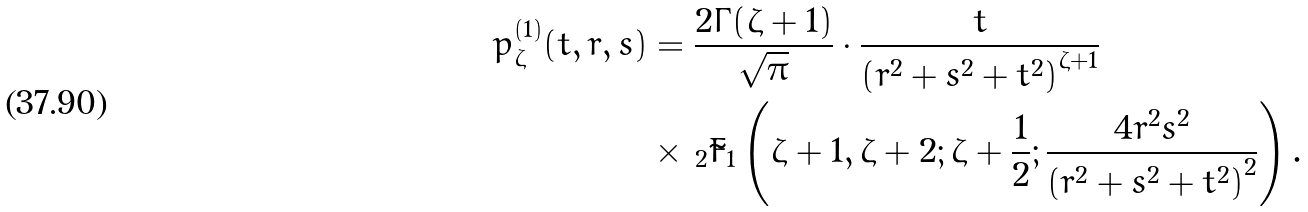<formula> <loc_0><loc_0><loc_500><loc_500>p _ { \zeta } ^ { ( 1 ) } ( t , r , s ) & = \frac { 2 \Gamma ( \zeta + 1 ) } { \sqrt { \pi } } \cdot \frac { t } { \left ( r ^ { 2 } + s ^ { 2 } + t ^ { 2 } \right ) ^ { \zeta + 1 } } \\ & \times \, _ { 2 } \tilde { F } _ { 1 } \left ( \zeta + 1 , \zeta + 2 ; \zeta + \frac { 1 } { 2 } ; \frac { 4 r ^ { 2 } s ^ { 2 } } { \left ( r ^ { 2 } + s ^ { 2 } + t ^ { 2 } \right ) ^ { 2 } } \right ) .</formula> 